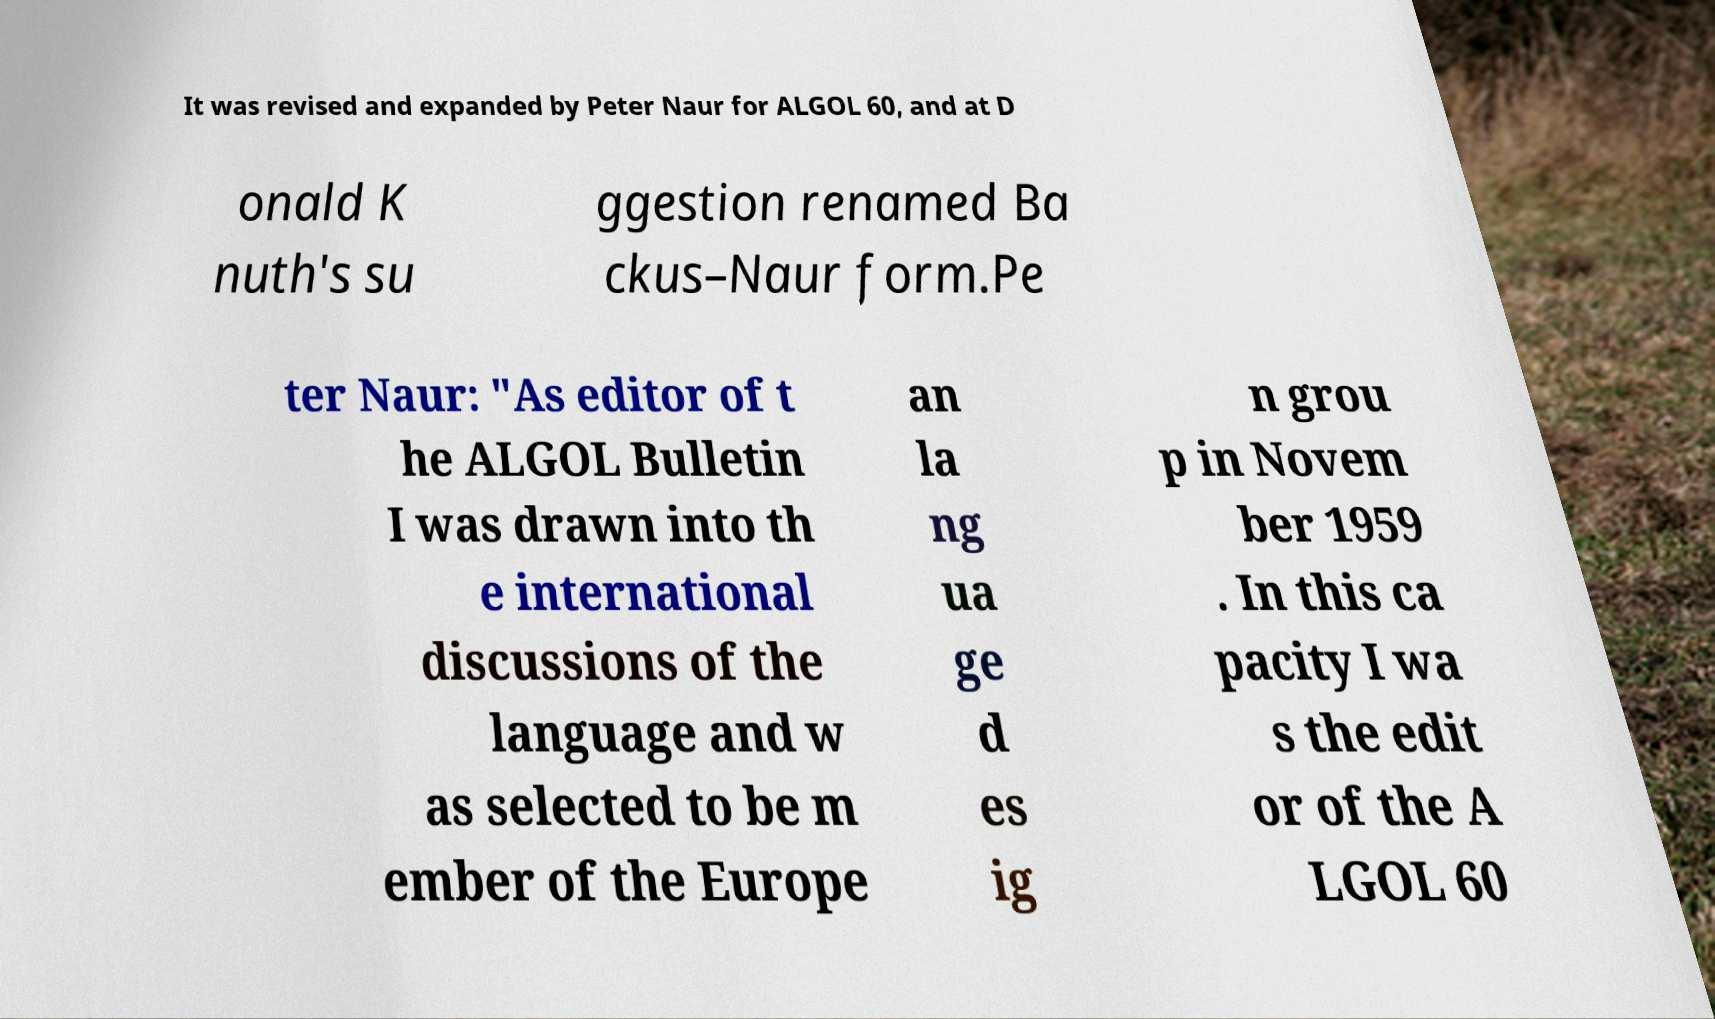I need the written content from this picture converted into text. Can you do that? It was revised and expanded by Peter Naur for ALGOL 60, and at D onald K nuth's su ggestion renamed Ba ckus–Naur form.Pe ter Naur: "As editor of t he ALGOL Bulletin I was drawn into th e international discussions of the language and w as selected to be m ember of the Europe an la ng ua ge d es ig n grou p in Novem ber 1959 . In this ca pacity I wa s the edit or of the A LGOL 60 